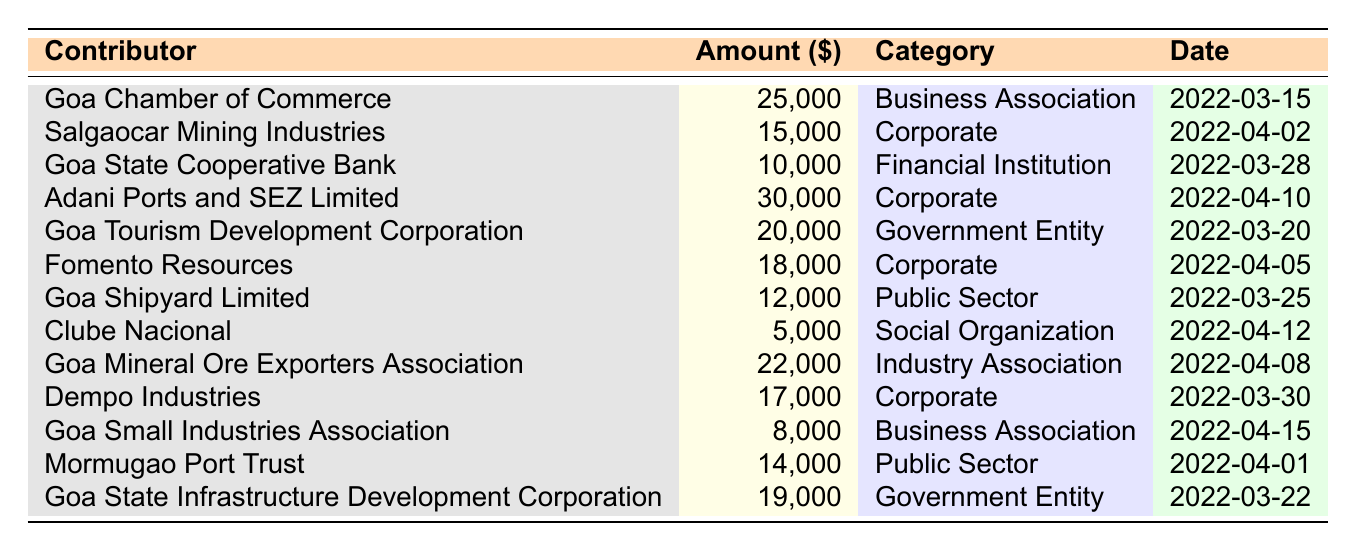What is the total amount contributed by corporate entities? The corporate contributions are: Salgaocar Mining Industries ($15,000), Adani Ports and SEZ Limited ($30,000), Fomento Resources ($18,000), and Dempo Industries ($17,000). Adding these together gives $15,000 + $30,000 + $18,000 + $17,000 = $80,000.
Answer: $80,000 Who contributed the highest amount? The highest amount contributed is $30,000 by Adani Ports and SEZ Limited, as seen in the table under the "Amount ($)" column.
Answer: Adani Ports and SEZ Limited How many contributions were made by business associations? The contributions from business associations are from Goa Chamber of Commerce ($25,000) and Goa Small Industries Association ($8,000), making a total of 2 contributions.
Answer: 2 Is there any contributor from a financial institution? Yes, the Goa State Cooperative Bank is listed as a financial institution, contributing $10,000 on March 28, 2022.
Answer: Yes What is the average contribution amount from government entities? The contributions from government entities are: Goa Tourism Development Corporation ($20,000) and Goa State Infrastructure Development Corporation ($19,000). Their average is calculated as (20,000 + 19,000) / 2 = $19,500.
Answer: $19,500 Which category has the highest total contribution? The total contributions by category are as follows: Corporate ($80,000), Government Entity ($39,000), Business Association ($33,000), Public Sector ($26,000), Financial Institution ($10,000), Social Organization ($5,000), and Industry Association ($22,000). The highest is Corporate with $80,000.
Answer: Corporate What was the contribution amount from the Goa Chamber of Commerce? The Goa Chamber of Commerce contributed $25,000, as indicated in the table under the "Amount ($)" column.
Answer: $25,000 How many contributors are categorized under public sector? There are two contributors in the public sector: Goa Shipyard Limited ($12,000) and Mormugao Port Trust ($14,000), therefore a total of 2 contributors.
Answer: 2 What is the total amount contributed on or before March 28, 2022? The contributions made on or before March 28, 2022 are: Goa Chamber of Commerce ($25,000), Goa State Cooperative Bank ($10,000), Goa Tourism Development Corporation ($20,000), Goa Shipyard Limited ($12,000), and Dempo Industries ($17,000). Summing these gives $25,000 + $10,000 + $20,000 + $12,000 + $17,000 = $94,000.
Answer: $94,000 Did any social organization contribute? Yes, Clube Nacional is listed as a social organization and contributed $5,000.
Answer: Yes 